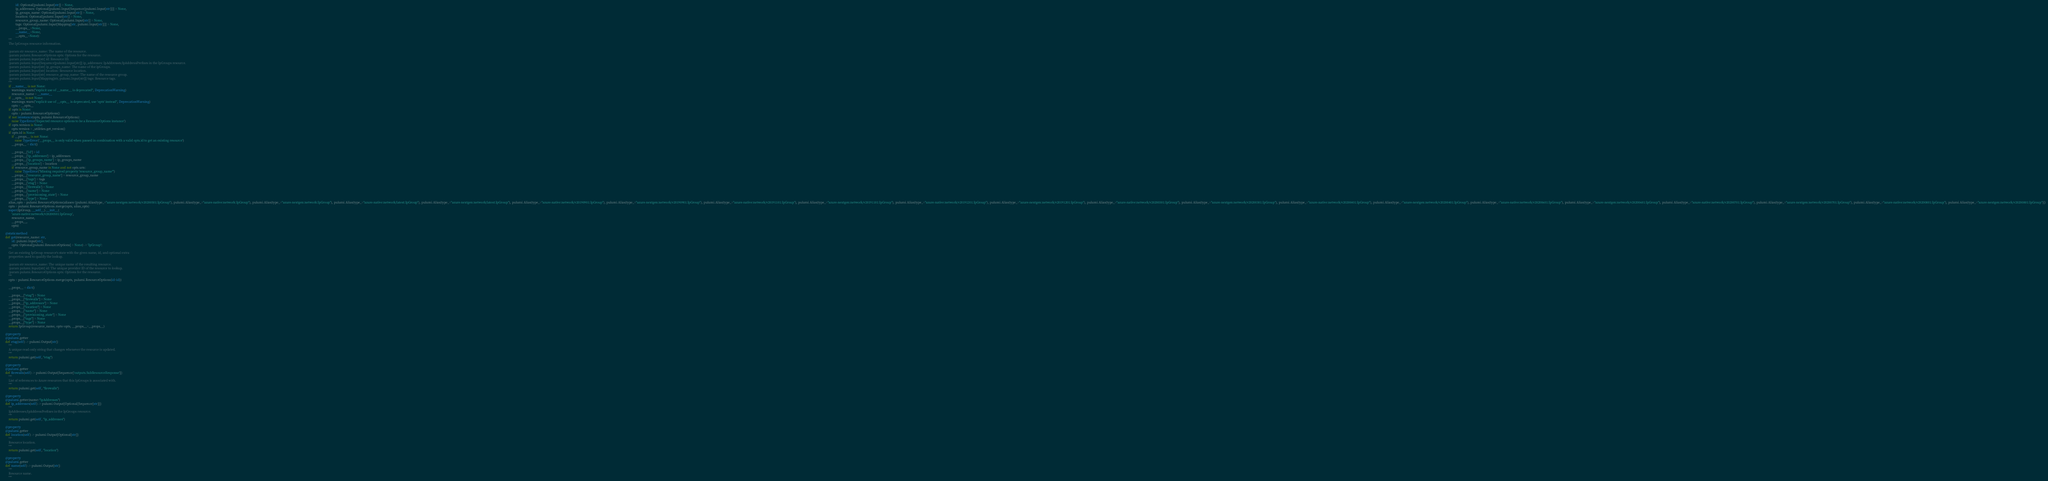<code> <loc_0><loc_0><loc_500><loc_500><_Python_>                 id: Optional[pulumi.Input[str]] = None,
                 ip_addresses: Optional[pulumi.Input[Sequence[pulumi.Input[str]]]] = None,
                 ip_groups_name: Optional[pulumi.Input[str]] = None,
                 location: Optional[pulumi.Input[str]] = None,
                 resource_group_name: Optional[pulumi.Input[str]] = None,
                 tags: Optional[pulumi.Input[Mapping[str, pulumi.Input[str]]]] = None,
                 __props__=None,
                 __name__=None,
                 __opts__=None):
        """
        The IpGroups resource information.

        :param str resource_name: The name of the resource.
        :param pulumi.ResourceOptions opts: Options for the resource.
        :param pulumi.Input[str] id: Resource ID.
        :param pulumi.Input[Sequence[pulumi.Input[str]]] ip_addresses: IpAddresses/IpAddressPrefixes in the IpGroups resource.
        :param pulumi.Input[str] ip_groups_name: The name of the ipGroups.
        :param pulumi.Input[str] location: Resource location.
        :param pulumi.Input[str] resource_group_name: The name of the resource group.
        :param pulumi.Input[Mapping[str, pulumi.Input[str]]] tags: Resource tags.
        """
        if __name__ is not None:
            warnings.warn("explicit use of __name__ is deprecated", DeprecationWarning)
            resource_name = __name__
        if __opts__ is not None:
            warnings.warn("explicit use of __opts__ is deprecated, use 'opts' instead", DeprecationWarning)
            opts = __opts__
        if opts is None:
            opts = pulumi.ResourceOptions()
        if not isinstance(opts, pulumi.ResourceOptions):
            raise TypeError('Expected resource options to be a ResourceOptions instance')
        if opts.version is None:
            opts.version = _utilities.get_version()
        if opts.id is None:
            if __props__ is not None:
                raise TypeError('__props__ is only valid when passed in combination with a valid opts.id to get an existing resource')
            __props__ = dict()

            __props__['id'] = id
            __props__['ip_addresses'] = ip_addresses
            __props__['ip_groups_name'] = ip_groups_name
            __props__['location'] = location
            if resource_group_name is None and not opts.urn:
                raise TypeError("Missing required property 'resource_group_name'")
            __props__['resource_group_name'] = resource_group_name
            __props__['tags'] = tags
            __props__['etag'] = None
            __props__['firewalls'] = None
            __props__['name'] = None
            __props__['provisioning_state'] = None
            __props__['type'] = None
        alias_opts = pulumi.ResourceOptions(aliases=[pulumi.Alias(type_="azure-nextgen:network/v20200501:IpGroup"), pulumi.Alias(type_="azure-native:network:IpGroup"), pulumi.Alias(type_="azure-nextgen:network:IpGroup"), pulumi.Alias(type_="azure-native:network/latest:IpGroup"), pulumi.Alias(type_="azure-nextgen:network/latest:IpGroup"), pulumi.Alias(type_="azure-native:network/v20190901:IpGroup"), pulumi.Alias(type_="azure-nextgen:network/v20190901:IpGroup"), pulumi.Alias(type_="azure-native:network/v20191101:IpGroup"), pulumi.Alias(type_="azure-nextgen:network/v20191101:IpGroup"), pulumi.Alias(type_="azure-native:network/v20191201:IpGroup"), pulumi.Alias(type_="azure-nextgen:network/v20191201:IpGroup"), pulumi.Alias(type_="azure-native:network/v20200301:IpGroup"), pulumi.Alias(type_="azure-nextgen:network/v20200301:IpGroup"), pulumi.Alias(type_="azure-native:network/v20200401:IpGroup"), pulumi.Alias(type_="azure-nextgen:network/v20200401:IpGroup"), pulumi.Alias(type_="azure-native:network/v20200601:IpGroup"), pulumi.Alias(type_="azure-nextgen:network/v20200601:IpGroup"), pulumi.Alias(type_="azure-native:network/v20200701:IpGroup"), pulumi.Alias(type_="azure-nextgen:network/v20200701:IpGroup"), pulumi.Alias(type_="azure-native:network/v20200801:IpGroup"), pulumi.Alias(type_="azure-nextgen:network/v20200801:IpGroup")])
        opts = pulumi.ResourceOptions.merge(opts, alias_opts)
        super(IpGroup, __self__).__init__(
            'azure-native:network/v20200501:IpGroup',
            resource_name,
            __props__,
            opts)

    @staticmethod
    def get(resource_name: str,
            id: pulumi.Input[str],
            opts: Optional[pulumi.ResourceOptions] = None) -> 'IpGroup':
        """
        Get an existing IpGroup resource's state with the given name, id, and optional extra
        properties used to qualify the lookup.

        :param str resource_name: The unique name of the resulting resource.
        :param pulumi.Input[str] id: The unique provider ID of the resource to lookup.
        :param pulumi.ResourceOptions opts: Options for the resource.
        """
        opts = pulumi.ResourceOptions.merge(opts, pulumi.ResourceOptions(id=id))

        __props__ = dict()

        __props__["etag"] = None
        __props__["firewalls"] = None
        __props__["ip_addresses"] = None
        __props__["location"] = None
        __props__["name"] = None
        __props__["provisioning_state"] = None
        __props__["tags"] = None
        __props__["type"] = None
        return IpGroup(resource_name, opts=opts, __props__=__props__)

    @property
    @pulumi.getter
    def etag(self) -> pulumi.Output[str]:
        """
        A unique read-only string that changes whenever the resource is updated.
        """
        return pulumi.get(self, "etag")

    @property
    @pulumi.getter
    def firewalls(self) -> pulumi.Output[Sequence['outputs.SubResourceResponse']]:
        """
        List of references to Azure resources that this IpGroups is associated with.
        """
        return pulumi.get(self, "firewalls")

    @property
    @pulumi.getter(name="ipAddresses")
    def ip_addresses(self) -> pulumi.Output[Optional[Sequence[str]]]:
        """
        IpAddresses/IpAddressPrefixes in the IpGroups resource.
        """
        return pulumi.get(self, "ip_addresses")

    @property
    @pulumi.getter
    def location(self) -> pulumi.Output[Optional[str]]:
        """
        Resource location.
        """
        return pulumi.get(self, "location")

    @property
    @pulumi.getter
    def name(self) -> pulumi.Output[str]:
        """
        Resource name.
        """</code> 